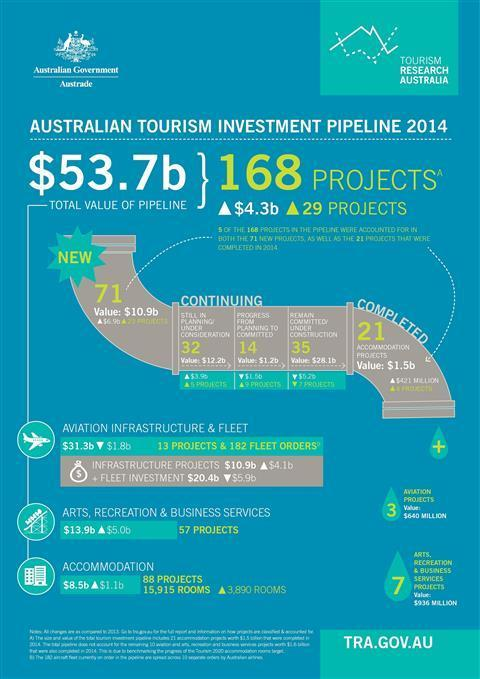what is the value of projects in pipeline
Answer the question with a short phrase. $53.7 b what is the value of aviation projects $640 million 